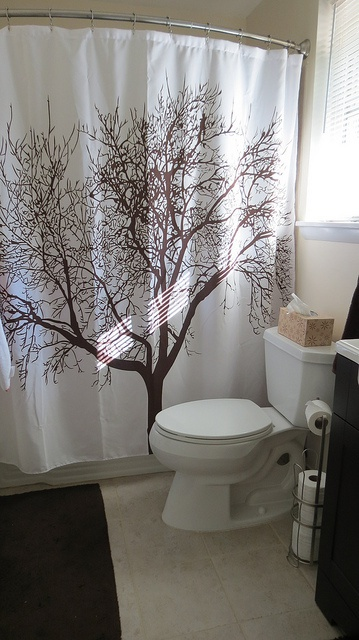Describe the objects in this image and their specific colors. I can see toilet in gray, darkgray, and black tones and sink in gray, darkgray, lightgray, and black tones in this image. 